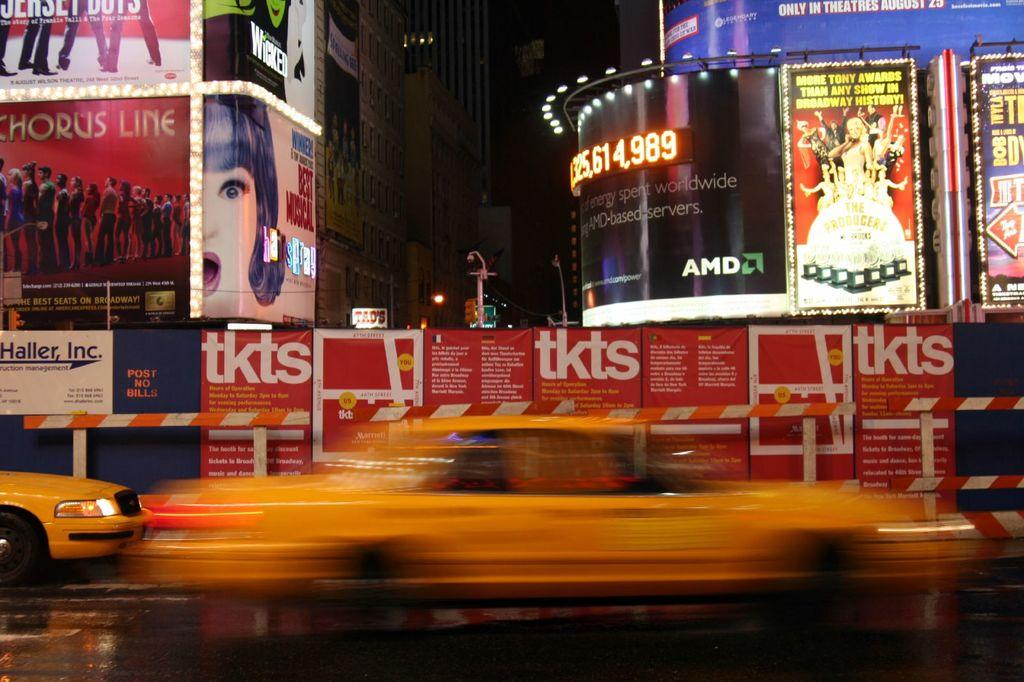<image>
Summarize the visual content of the image. A taxi is blurring past a tkts sign and ads for A Chorus Line. 